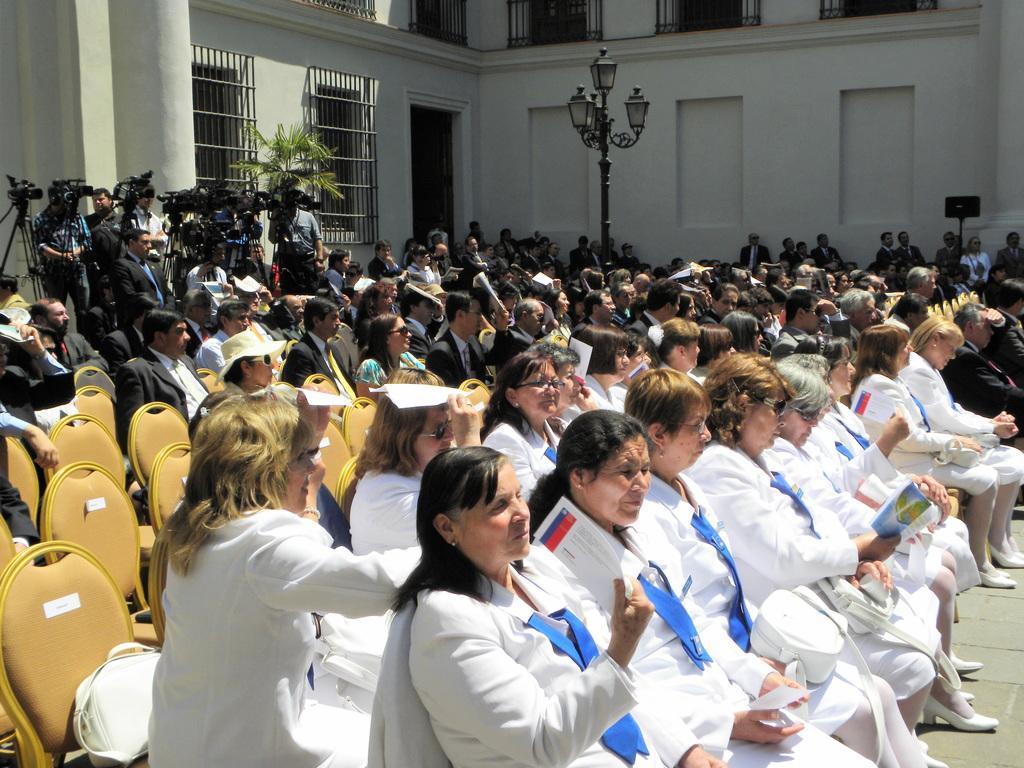How would you summarize this image in a sentence or two? In this image we can see a group of people sitting on the chairs. In that some are holding the papers. On the backside we can see the cameras with stand, some people standing, a building with windows and metal grills, a plant, a street lamp and a speaker to a stand. 